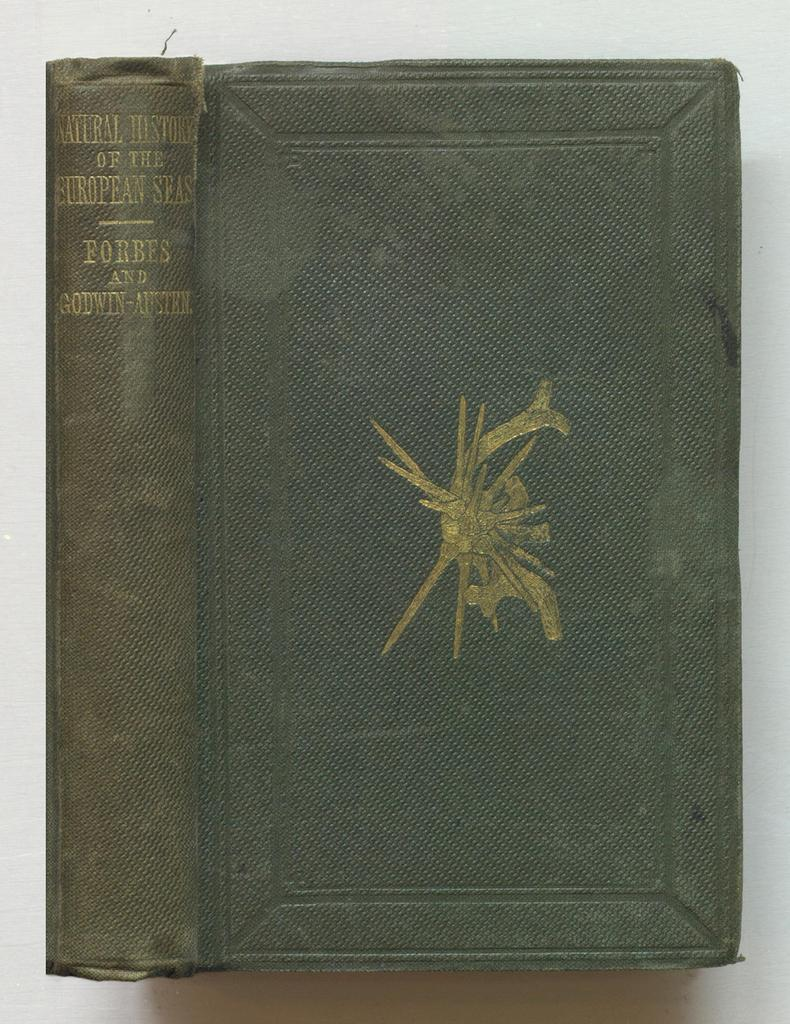<image>
Provide a brief description of the given image. The Natural History of the European Seas book has a discolored spine. 